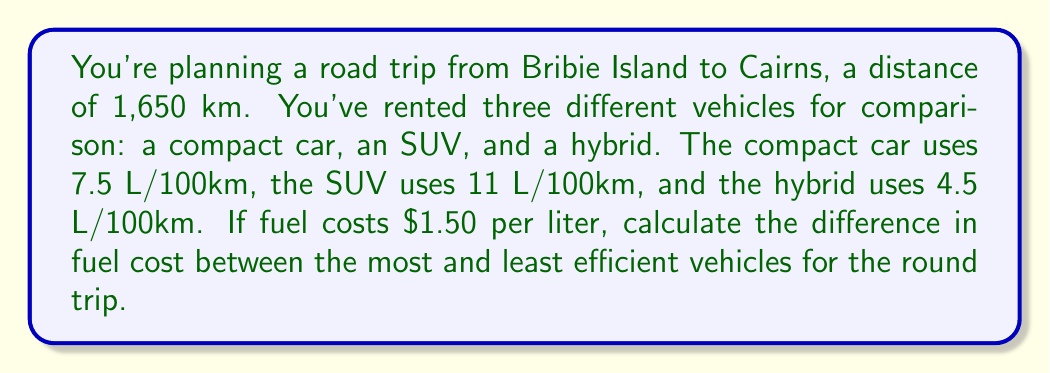Give your solution to this math problem. Let's approach this step-by-step:

1) First, calculate the total distance for the round trip:
   $$1,650 \text{ km} \times 2 = 3,300 \text{ km}$$

2) Now, calculate the fuel consumption for each vehicle:
   
   Compact car: $$3,300 \text{ km} \times \frac{7.5 \text{ L}}{100 \text{ km}} = 247.5 \text{ L}$$
   
   SUV: $$3,300 \text{ km} \times \frac{11 \text{ L}}{100 \text{ km}} = 363 \text{ L}$$
   
   Hybrid: $$3,300 \text{ km} \times \frac{4.5 \text{ L}}{100 \text{ km}} = 148.5 \text{ L}$$

3) Calculate the fuel cost for each vehicle:
   
   Compact car: $$247.5 \text{ L} \times $1.50/\text{L} = $371.25$$
   
   SUV: $$363 \text{ L} \times $1.50/\text{L} = $544.50$$
   
   Hybrid: $$148.5 \text{ L} \times $1.50/\text{L} = $222.75$$

4) The most efficient vehicle is the hybrid, and the least efficient is the SUV.

5) Calculate the difference in fuel cost:
   $$544.50 - 222.75 = $321.75$$
Answer: $321.75 